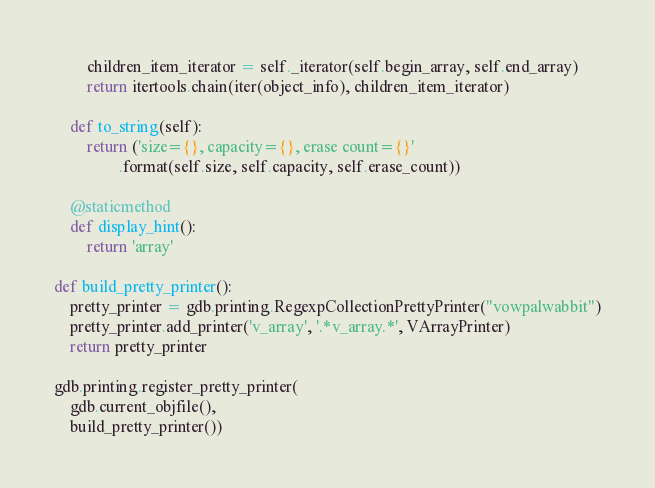Convert code to text. <code><loc_0><loc_0><loc_500><loc_500><_Python_>        children_item_iterator = self._iterator(self.begin_array, self.end_array)
        return itertools.chain(iter(object_info), children_item_iterator)

    def to_string(self):
        return ('size={}, capacity={}, erase count={}'
                .format(self.size, self.capacity, self.erase_count))

    @staticmethod
    def display_hint():
        return 'array'

def build_pretty_printer():
    pretty_printer = gdb.printing.RegexpCollectionPrettyPrinter("vowpalwabbit")
    pretty_printer.add_printer('v_array', '.*v_array.*', VArrayPrinter)
    return pretty_printer

gdb.printing.register_pretty_printer(
    gdb.current_objfile(),
    build_pretty_printer())
</code> 